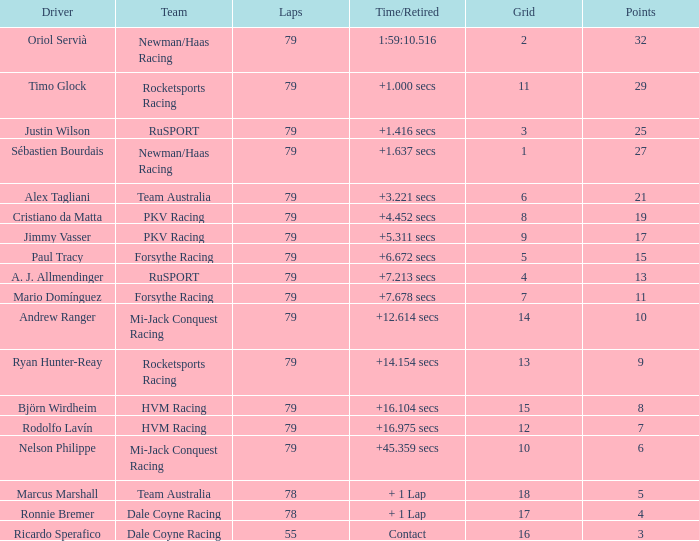Which points has the driver Paul Tracy? 15.0. 